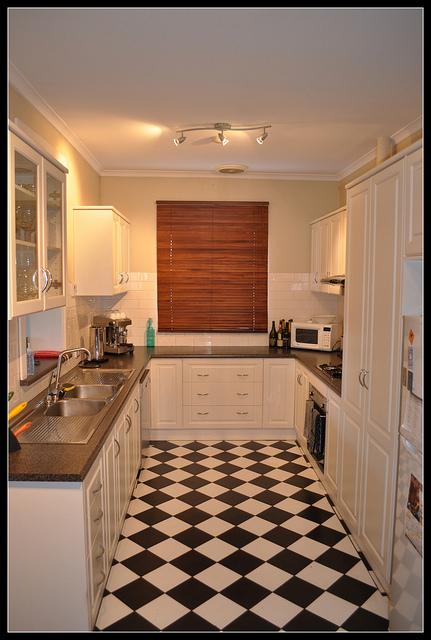How many black tiles are there?
Concise answer only. 50. What is the panel on the back wall made out of?
Keep it brief. Wood. What the pattern on the floor called?
Write a very short answer. Checkered. 